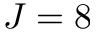<formula> <loc_0><loc_0><loc_500><loc_500>J = 8</formula> 